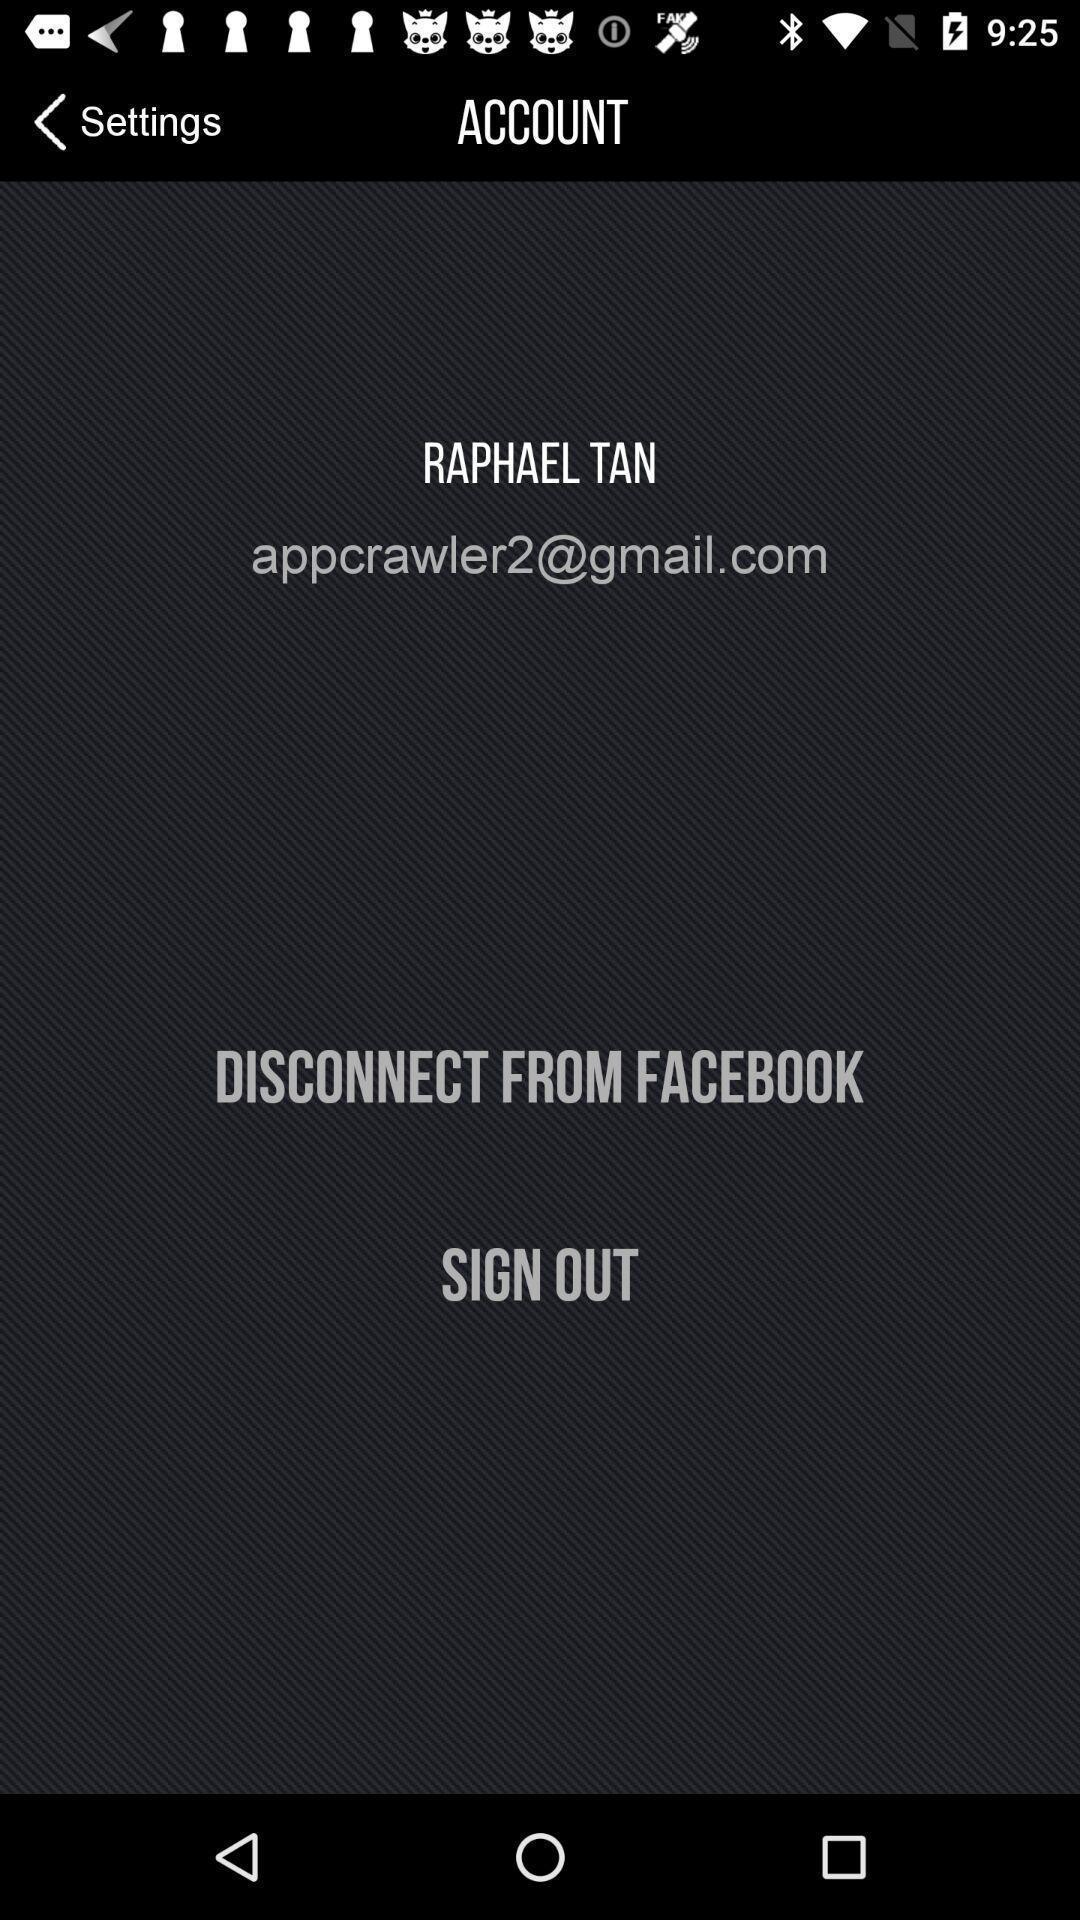Summarize the information in this screenshot. Sign out page of a social app. 